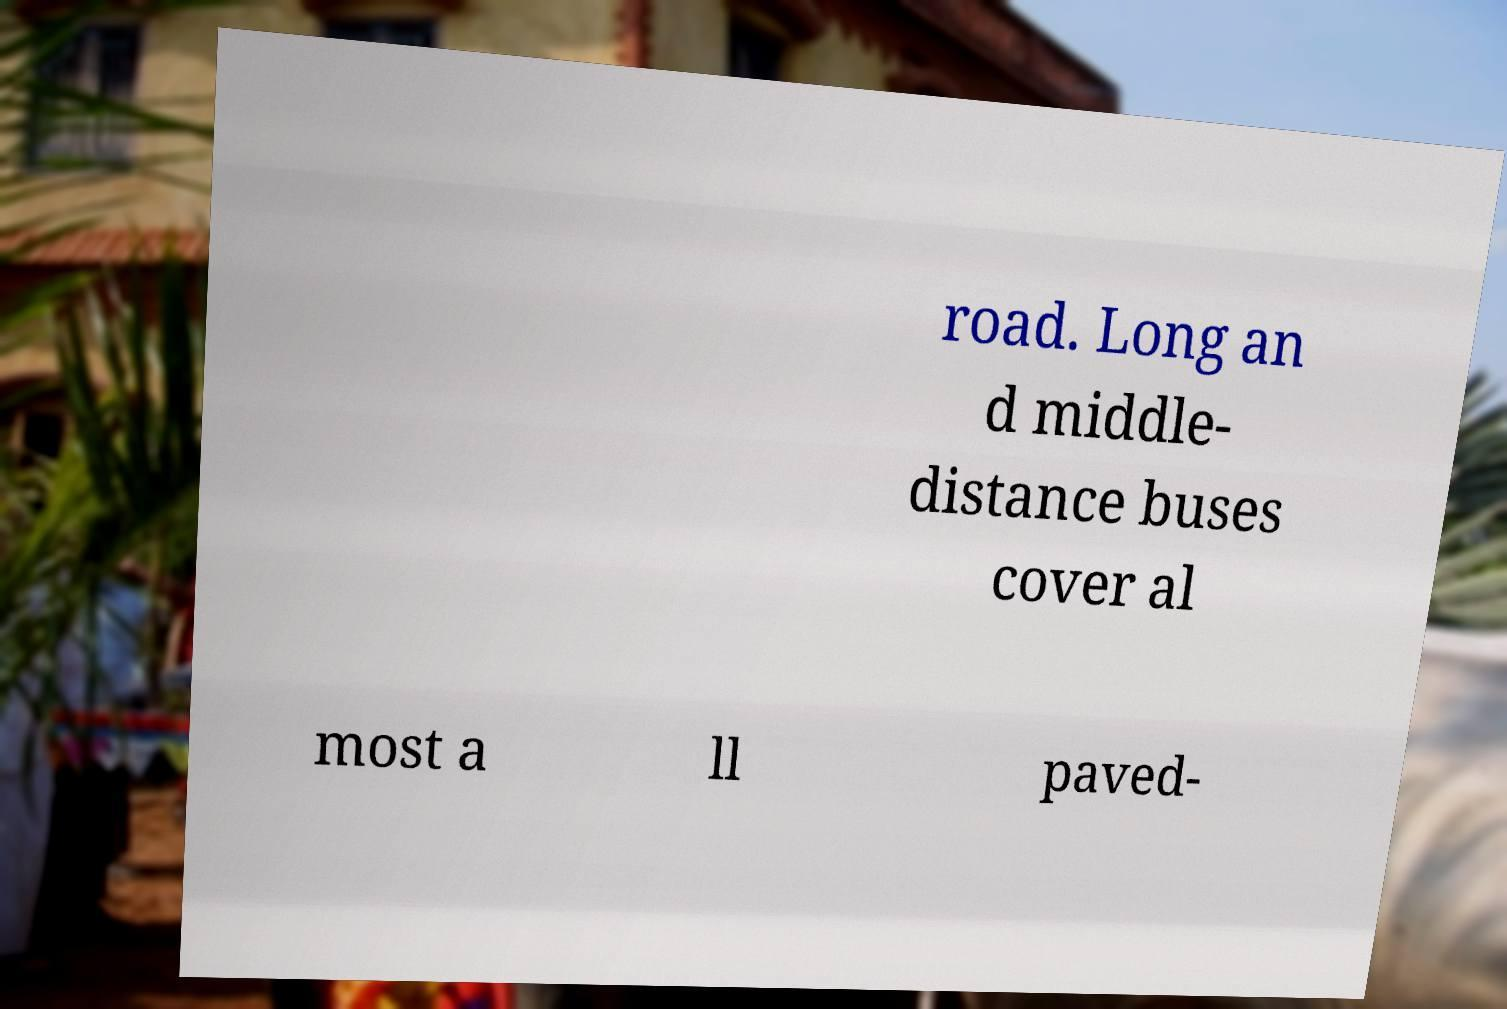I need the written content from this picture converted into text. Can you do that? road. Long an d middle- distance buses cover al most a ll paved- 